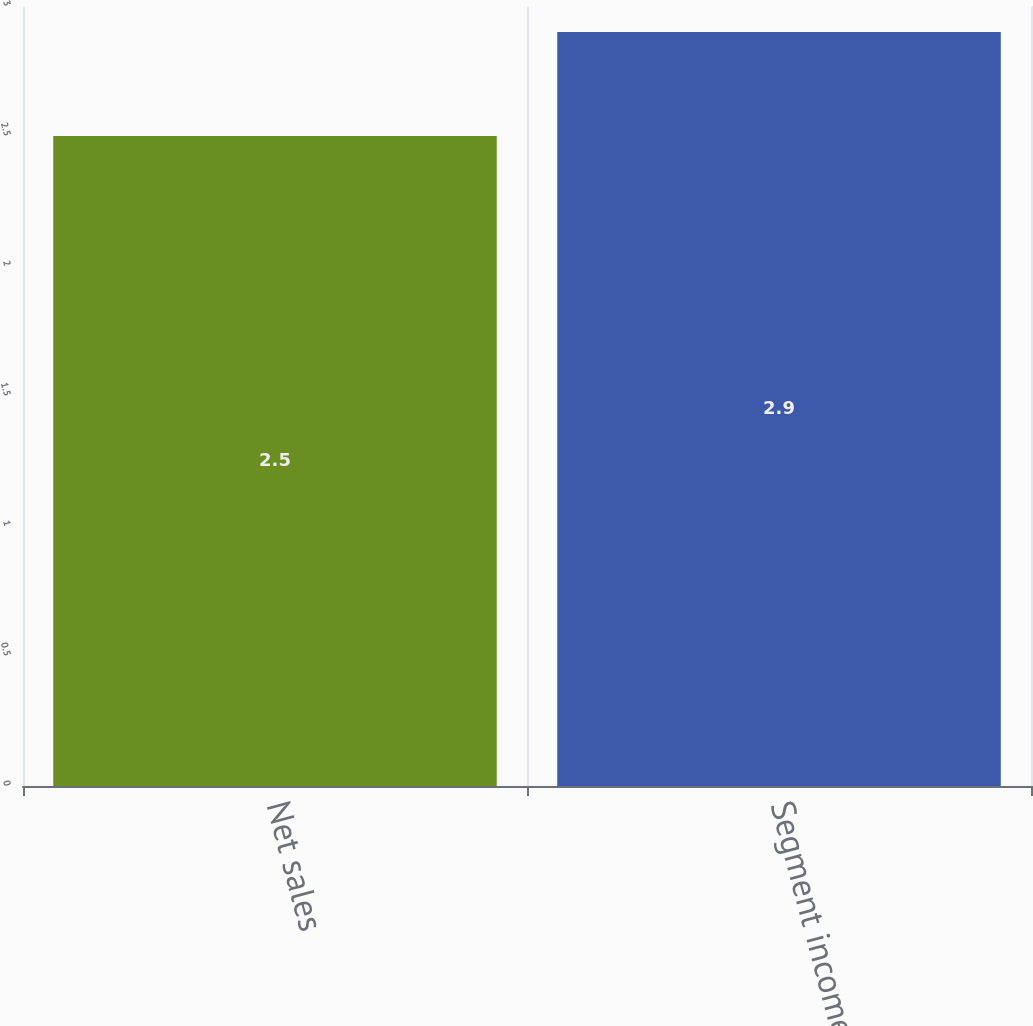Convert chart. <chart><loc_0><loc_0><loc_500><loc_500><bar_chart><fcel>Net sales<fcel>Segment income<nl><fcel>2.5<fcel>2.9<nl></chart> 